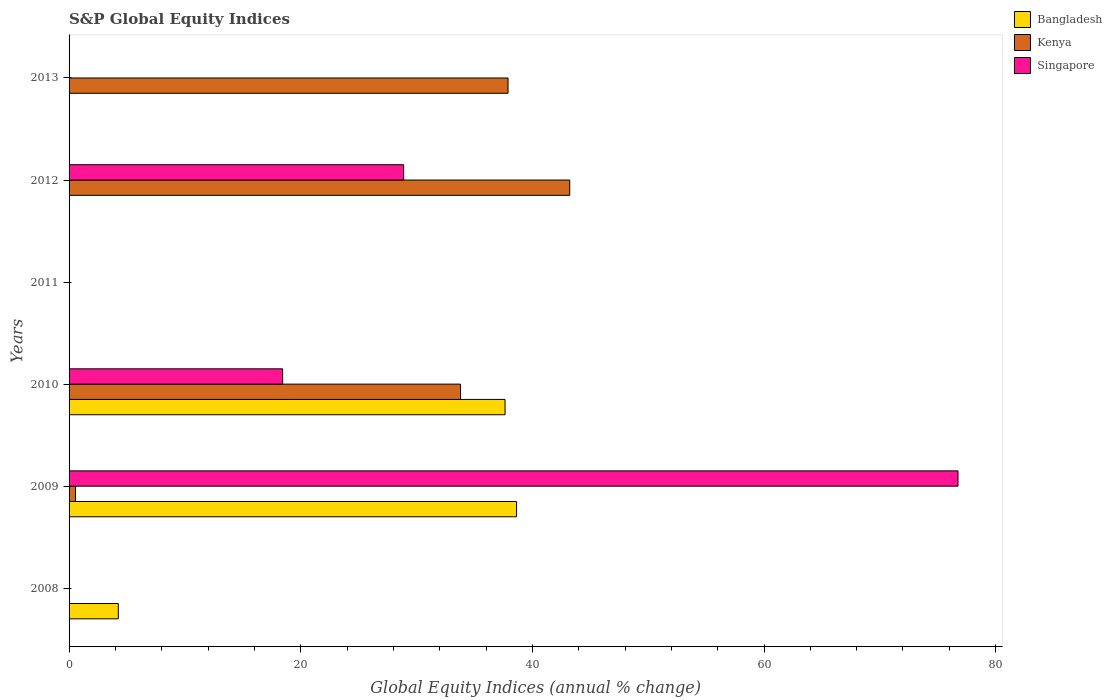How many different coloured bars are there?
Your answer should be compact. 3. Are the number of bars per tick equal to the number of legend labels?
Provide a short and direct response. No. Are the number of bars on each tick of the Y-axis equal?
Ensure brevity in your answer.  No. How many bars are there on the 5th tick from the top?
Ensure brevity in your answer.  3. What is the label of the 1st group of bars from the top?
Your answer should be compact. 2013. What is the global equity indices in Bangladesh in 2012?
Keep it short and to the point. 0. Across all years, what is the maximum global equity indices in Bangladesh?
Keep it short and to the point. 38.64. Across all years, what is the minimum global equity indices in Bangladesh?
Ensure brevity in your answer.  0. In which year was the global equity indices in Kenya maximum?
Provide a short and direct response. 2012. What is the total global equity indices in Bangladesh in the graph?
Your answer should be very brief. 80.53. What is the average global equity indices in Singapore per year?
Keep it short and to the point. 20.68. In the year 2012, what is the difference between the global equity indices in Kenya and global equity indices in Singapore?
Offer a very short reply. 14.34. In how many years, is the global equity indices in Kenya greater than 36 %?
Offer a very short reply. 2. Is the difference between the global equity indices in Kenya in 2009 and 2012 greater than the difference between the global equity indices in Singapore in 2009 and 2012?
Your answer should be compact. No. What is the difference between the highest and the second highest global equity indices in Singapore?
Your response must be concise. 47.86. What is the difference between the highest and the lowest global equity indices in Kenya?
Give a very brief answer. 43.23. In how many years, is the global equity indices in Kenya greater than the average global equity indices in Kenya taken over all years?
Ensure brevity in your answer.  3. Are all the bars in the graph horizontal?
Provide a succinct answer. Yes. Are the values on the major ticks of X-axis written in scientific E-notation?
Give a very brief answer. No. Does the graph contain grids?
Give a very brief answer. No. Where does the legend appear in the graph?
Keep it short and to the point. Top right. How many legend labels are there?
Your answer should be very brief. 3. What is the title of the graph?
Provide a succinct answer. S&P Global Equity Indices. Does "Equatorial Guinea" appear as one of the legend labels in the graph?
Make the answer very short. No. What is the label or title of the X-axis?
Give a very brief answer. Global Equity Indices (annual % change). What is the Global Equity Indices (annual % change) of Bangladesh in 2008?
Your response must be concise. 4.25. What is the Global Equity Indices (annual % change) in Bangladesh in 2009?
Offer a very short reply. 38.64. What is the Global Equity Indices (annual % change) of Kenya in 2009?
Provide a short and direct response. 0.56. What is the Global Equity Indices (annual % change) of Singapore in 2009?
Make the answer very short. 76.75. What is the Global Equity Indices (annual % change) of Bangladesh in 2010?
Offer a very short reply. 37.64. What is the Global Equity Indices (annual % change) in Kenya in 2010?
Provide a succinct answer. 33.8. What is the Global Equity Indices (annual % change) in Singapore in 2010?
Provide a short and direct response. 18.44. What is the Global Equity Indices (annual % change) of Bangladesh in 2011?
Offer a very short reply. 0. What is the Global Equity Indices (annual % change) in Kenya in 2011?
Keep it short and to the point. 0. What is the Global Equity Indices (annual % change) in Singapore in 2011?
Your response must be concise. 0. What is the Global Equity Indices (annual % change) in Kenya in 2012?
Provide a succinct answer. 43.23. What is the Global Equity Indices (annual % change) of Singapore in 2012?
Ensure brevity in your answer.  28.89. What is the Global Equity Indices (annual % change) in Kenya in 2013?
Your answer should be very brief. 37.9. Across all years, what is the maximum Global Equity Indices (annual % change) in Bangladesh?
Provide a short and direct response. 38.64. Across all years, what is the maximum Global Equity Indices (annual % change) of Kenya?
Keep it short and to the point. 43.23. Across all years, what is the maximum Global Equity Indices (annual % change) of Singapore?
Offer a terse response. 76.75. Across all years, what is the minimum Global Equity Indices (annual % change) of Singapore?
Ensure brevity in your answer.  0. What is the total Global Equity Indices (annual % change) in Bangladesh in the graph?
Keep it short and to the point. 80.53. What is the total Global Equity Indices (annual % change) of Kenya in the graph?
Keep it short and to the point. 115.48. What is the total Global Equity Indices (annual % change) of Singapore in the graph?
Make the answer very short. 124.07. What is the difference between the Global Equity Indices (annual % change) in Bangladesh in 2008 and that in 2009?
Your answer should be very brief. -34.38. What is the difference between the Global Equity Indices (annual % change) in Bangladesh in 2008 and that in 2010?
Keep it short and to the point. -33.39. What is the difference between the Global Equity Indices (annual % change) of Kenya in 2009 and that in 2010?
Keep it short and to the point. -33.24. What is the difference between the Global Equity Indices (annual % change) of Singapore in 2009 and that in 2010?
Ensure brevity in your answer.  58.31. What is the difference between the Global Equity Indices (annual % change) of Kenya in 2009 and that in 2012?
Offer a very short reply. -42.67. What is the difference between the Global Equity Indices (annual % change) in Singapore in 2009 and that in 2012?
Ensure brevity in your answer.  47.86. What is the difference between the Global Equity Indices (annual % change) of Kenya in 2009 and that in 2013?
Ensure brevity in your answer.  -37.35. What is the difference between the Global Equity Indices (annual % change) of Kenya in 2010 and that in 2012?
Your response must be concise. -9.43. What is the difference between the Global Equity Indices (annual % change) of Singapore in 2010 and that in 2012?
Make the answer very short. -10.45. What is the difference between the Global Equity Indices (annual % change) of Kenya in 2010 and that in 2013?
Your answer should be compact. -4.1. What is the difference between the Global Equity Indices (annual % change) in Kenya in 2012 and that in 2013?
Provide a succinct answer. 5.33. What is the difference between the Global Equity Indices (annual % change) in Bangladesh in 2008 and the Global Equity Indices (annual % change) in Kenya in 2009?
Offer a very short reply. 3.7. What is the difference between the Global Equity Indices (annual % change) in Bangladesh in 2008 and the Global Equity Indices (annual % change) in Singapore in 2009?
Keep it short and to the point. -72.5. What is the difference between the Global Equity Indices (annual % change) in Bangladesh in 2008 and the Global Equity Indices (annual % change) in Kenya in 2010?
Provide a succinct answer. -29.54. What is the difference between the Global Equity Indices (annual % change) of Bangladesh in 2008 and the Global Equity Indices (annual % change) of Singapore in 2010?
Ensure brevity in your answer.  -14.19. What is the difference between the Global Equity Indices (annual % change) of Bangladesh in 2008 and the Global Equity Indices (annual % change) of Kenya in 2012?
Offer a terse response. -38.97. What is the difference between the Global Equity Indices (annual % change) of Bangladesh in 2008 and the Global Equity Indices (annual % change) of Singapore in 2012?
Keep it short and to the point. -24.63. What is the difference between the Global Equity Indices (annual % change) of Bangladesh in 2008 and the Global Equity Indices (annual % change) of Kenya in 2013?
Provide a short and direct response. -33.65. What is the difference between the Global Equity Indices (annual % change) in Bangladesh in 2009 and the Global Equity Indices (annual % change) in Kenya in 2010?
Provide a succinct answer. 4.84. What is the difference between the Global Equity Indices (annual % change) of Bangladesh in 2009 and the Global Equity Indices (annual % change) of Singapore in 2010?
Ensure brevity in your answer.  20.2. What is the difference between the Global Equity Indices (annual % change) of Kenya in 2009 and the Global Equity Indices (annual % change) of Singapore in 2010?
Offer a very short reply. -17.88. What is the difference between the Global Equity Indices (annual % change) in Bangladesh in 2009 and the Global Equity Indices (annual % change) in Kenya in 2012?
Provide a succinct answer. -4.59. What is the difference between the Global Equity Indices (annual % change) of Bangladesh in 2009 and the Global Equity Indices (annual % change) of Singapore in 2012?
Provide a succinct answer. 9.75. What is the difference between the Global Equity Indices (annual % change) in Kenya in 2009 and the Global Equity Indices (annual % change) in Singapore in 2012?
Give a very brief answer. -28.33. What is the difference between the Global Equity Indices (annual % change) of Bangladesh in 2009 and the Global Equity Indices (annual % change) of Kenya in 2013?
Provide a succinct answer. 0.74. What is the difference between the Global Equity Indices (annual % change) in Bangladesh in 2010 and the Global Equity Indices (annual % change) in Kenya in 2012?
Offer a very short reply. -5.59. What is the difference between the Global Equity Indices (annual % change) of Bangladesh in 2010 and the Global Equity Indices (annual % change) of Singapore in 2012?
Offer a very short reply. 8.76. What is the difference between the Global Equity Indices (annual % change) in Kenya in 2010 and the Global Equity Indices (annual % change) in Singapore in 2012?
Your response must be concise. 4.91. What is the difference between the Global Equity Indices (annual % change) of Bangladesh in 2010 and the Global Equity Indices (annual % change) of Kenya in 2013?
Give a very brief answer. -0.26. What is the average Global Equity Indices (annual % change) in Bangladesh per year?
Offer a terse response. 13.42. What is the average Global Equity Indices (annual % change) of Kenya per year?
Your answer should be very brief. 19.25. What is the average Global Equity Indices (annual % change) of Singapore per year?
Provide a short and direct response. 20.68. In the year 2009, what is the difference between the Global Equity Indices (annual % change) in Bangladesh and Global Equity Indices (annual % change) in Kenya?
Make the answer very short. 38.08. In the year 2009, what is the difference between the Global Equity Indices (annual % change) of Bangladesh and Global Equity Indices (annual % change) of Singapore?
Your answer should be very brief. -38.11. In the year 2009, what is the difference between the Global Equity Indices (annual % change) in Kenya and Global Equity Indices (annual % change) in Singapore?
Provide a succinct answer. -76.19. In the year 2010, what is the difference between the Global Equity Indices (annual % change) in Bangladesh and Global Equity Indices (annual % change) in Kenya?
Make the answer very short. 3.84. In the year 2010, what is the difference between the Global Equity Indices (annual % change) of Bangladesh and Global Equity Indices (annual % change) of Singapore?
Provide a succinct answer. 19.2. In the year 2010, what is the difference between the Global Equity Indices (annual % change) of Kenya and Global Equity Indices (annual % change) of Singapore?
Offer a very short reply. 15.36. In the year 2012, what is the difference between the Global Equity Indices (annual % change) in Kenya and Global Equity Indices (annual % change) in Singapore?
Ensure brevity in your answer.  14.34. What is the ratio of the Global Equity Indices (annual % change) in Bangladesh in 2008 to that in 2009?
Offer a very short reply. 0.11. What is the ratio of the Global Equity Indices (annual % change) of Bangladesh in 2008 to that in 2010?
Give a very brief answer. 0.11. What is the ratio of the Global Equity Indices (annual % change) in Bangladesh in 2009 to that in 2010?
Your answer should be very brief. 1.03. What is the ratio of the Global Equity Indices (annual % change) of Kenya in 2009 to that in 2010?
Your answer should be very brief. 0.02. What is the ratio of the Global Equity Indices (annual % change) of Singapore in 2009 to that in 2010?
Your response must be concise. 4.16. What is the ratio of the Global Equity Indices (annual % change) in Kenya in 2009 to that in 2012?
Give a very brief answer. 0.01. What is the ratio of the Global Equity Indices (annual % change) of Singapore in 2009 to that in 2012?
Provide a succinct answer. 2.66. What is the ratio of the Global Equity Indices (annual % change) of Kenya in 2009 to that in 2013?
Offer a terse response. 0.01. What is the ratio of the Global Equity Indices (annual % change) in Kenya in 2010 to that in 2012?
Provide a succinct answer. 0.78. What is the ratio of the Global Equity Indices (annual % change) of Singapore in 2010 to that in 2012?
Your answer should be very brief. 0.64. What is the ratio of the Global Equity Indices (annual % change) in Kenya in 2010 to that in 2013?
Keep it short and to the point. 0.89. What is the ratio of the Global Equity Indices (annual % change) in Kenya in 2012 to that in 2013?
Make the answer very short. 1.14. What is the difference between the highest and the second highest Global Equity Indices (annual % change) in Kenya?
Provide a short and direct response. 5.33. What is the difference between the highest and the second highest Global Equity Indices (annual % change) in Singapore?
Your answer should be compact. 47.86. What is the difference between the highest and the lowest Global Equity Indices (annual % change) in Bangladesh?
Give a very brief answer. 38.64. What is the difference between the highest and the lowest Global Equity Indices (annual % change) in Kenya?
Offer a terse response. 43.23. What is the difference between the highest and the lowest Global Equity Indices (annual % change) of Singapore?
Give a very brief answer. 76.75. 